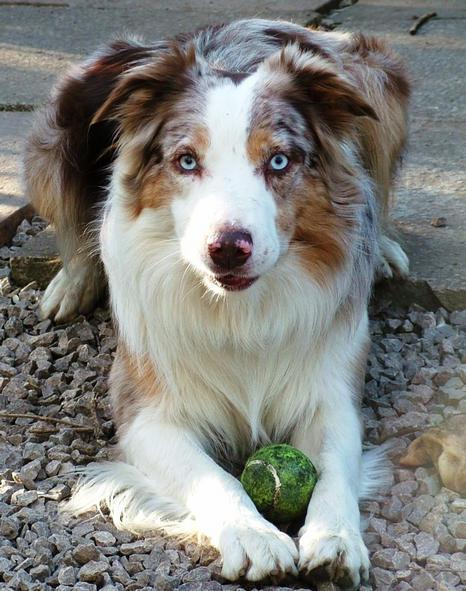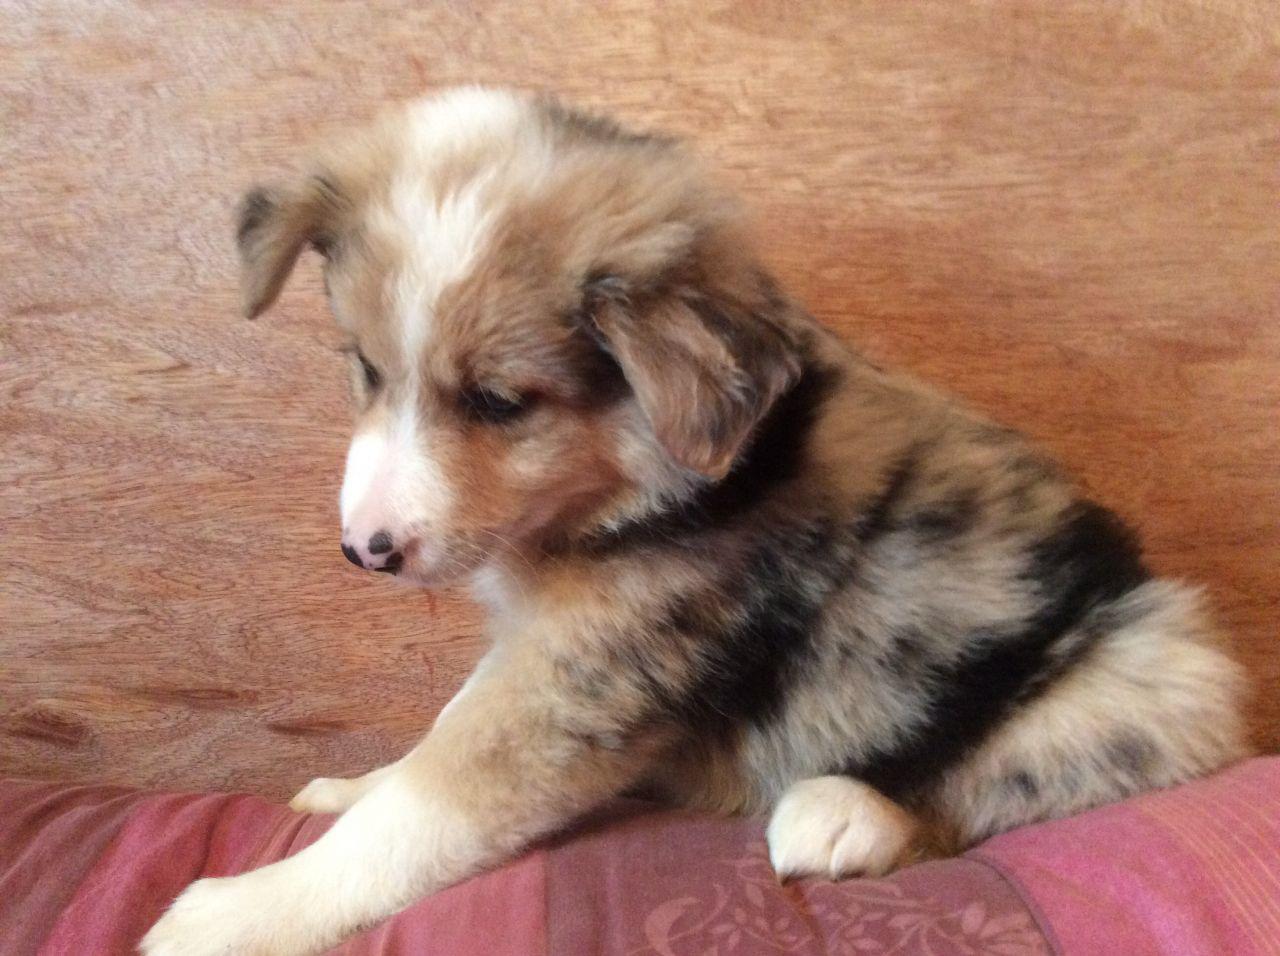The first image is the image on the left, the second image is the image on the right. For the images displayed, is the sentence "A dog has its mouth open and showing its tongue." factually correct? Answer yes or no. No. The first image is the image on the left, the second image is the image on the right. Assess this claim about the two images: "One image shows a spotted puppy in a non-standing position, with both front paws extended.". Correct or not? Answer yes or no. Yes. 